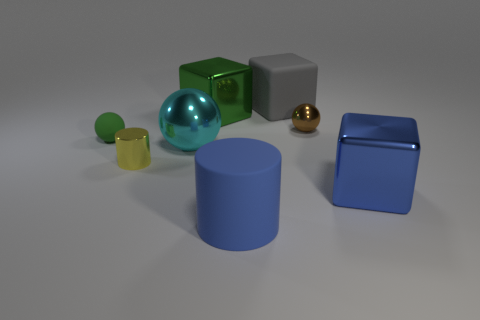Is the size of the brown shiny thing the same as the gray rubber block?
Offer a very short reply. No. Are there any other things that are the same color as the matte ball?
Keep it short and to the point. Yes. There is a thing that is both in front of the cyan metallic ball and left of the big cyan shiny thing; what is its shape?
Provide a succinct answer. Cylinder. What is the size of the metal block that is to the right of the large cylinder?
Offer a terse response. Large. What number of big things are on the right side of the cube to the right of the big matte thing that is behind the green ball?
Your answer should be very brief. 0. Are there any large matte objects in front of the big cylinder?
Provide a succinct answer. No. What number of other objects are the same size as the yellow metallic cylinder?
Ensure brevity in your answer.  2. There is a small object that is both behind the yellow shiny thing and to the left of the green cube; what material is it?
Provide a succinct answer. Rubber. Is the shape of the large metallic object on the left side of the green block the same as the big metallic thing right of the green shiny block?
Provide a succinct answer. No. What shape is the tiny shiny object right of the cyan ball to the right of the cylinder that is left of the big shiny ball?
Ensure brevity in your answer.  Sphere. 